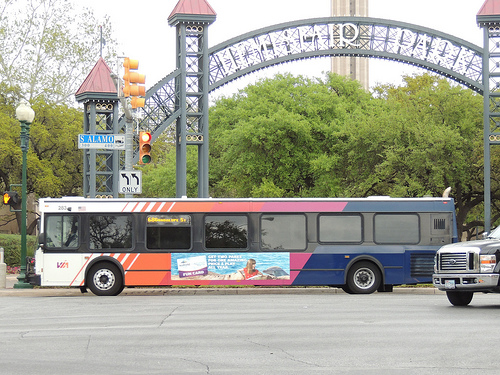<image>
Can you confirm if the pillar is behind the bus? Yes. From this viewpoint, the pillar is positioned behind the bus, with the bus partially or fully occluding the pillar. Where is the street light in relation to the transit bus? Is it behind the transit bus? No. The street light is not behind the transit bus. From this viewpoint, the street light appears to be positioned elsewhere in the scene. Is the bus to the right of the car? Yes. From this viewpoint, the bus is positioned to the right side relative to the car. 